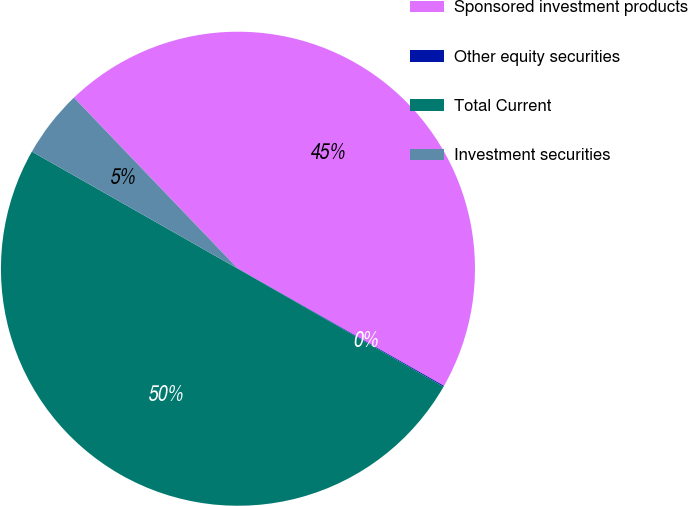<chart> <loc_0><loc_0><loc_500><loc_500><pie_chart><fcel>Sponsored investment products<fcel>Other equity securities<fcel>Total Current<fcel>Investment securities<nl><fcel>45.39%<fcel>0.07%<fcel>49.93%<fcel>4.61%<nl></chart> 